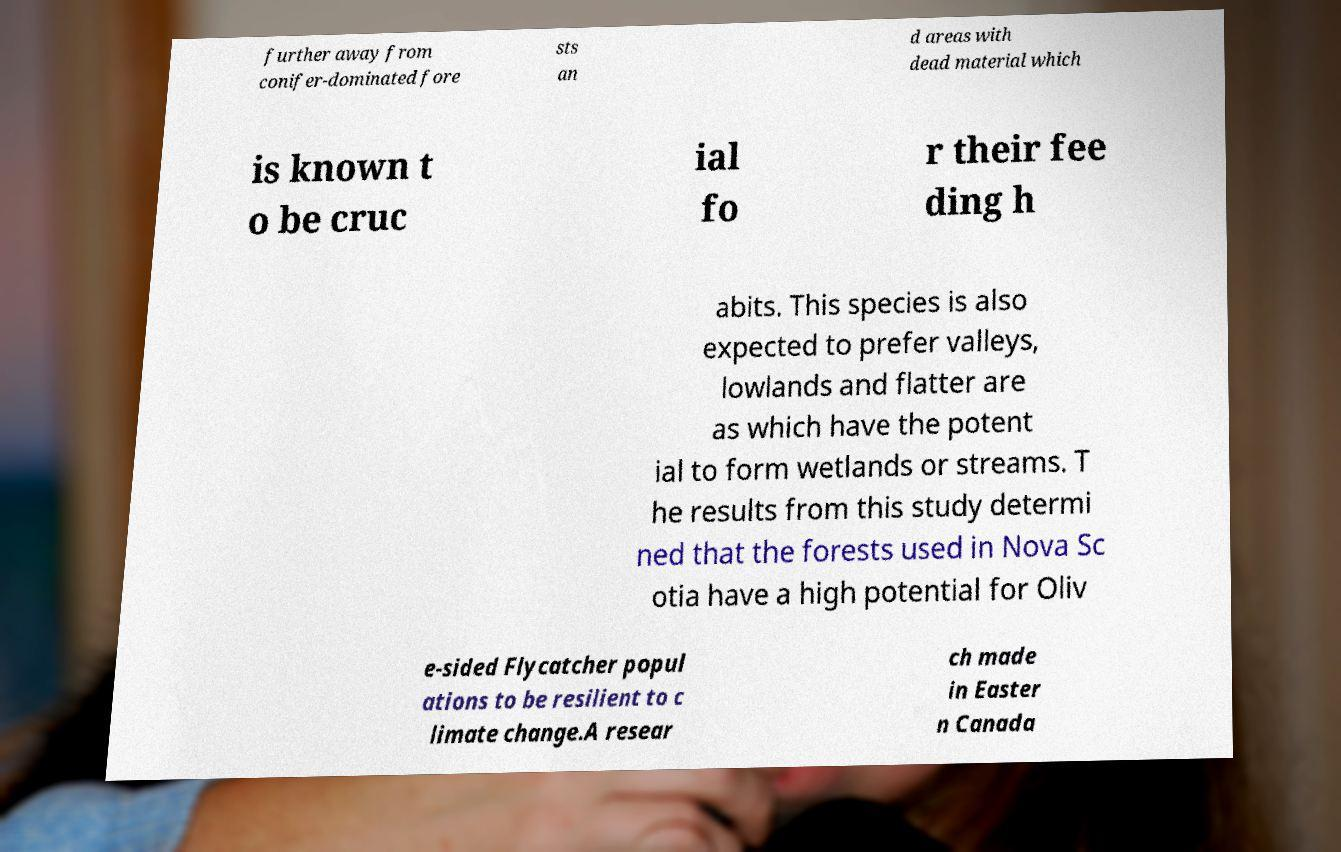Please identify and transcribe the text found in this image. further away from conifer-dominated fore sts an d areas with dead material which is known t o be cruc ial fo r their fee ding h abits. This species is also expected to prefer valleys, lowlands and flatter are as which have the potent ial to form wetlands or streams. T he results from this study determi ned that the forests used in Nova Sc otia have a high potential for Oliv e-sided Flycatcher popul ations to be resilient to c limate change.A resear ch made in Easter n Canada 